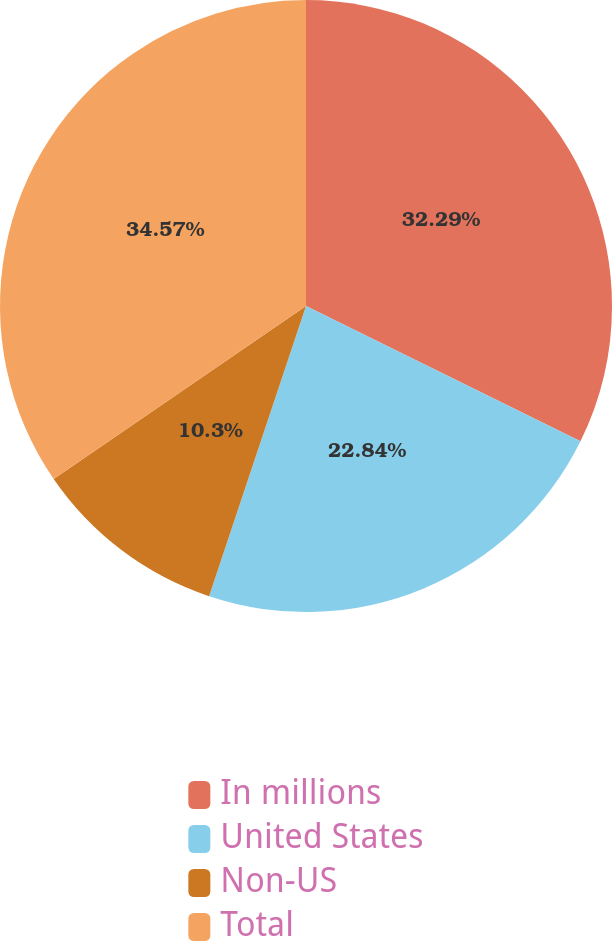Convert chart. <chart><loc_0><loc_0><loc_500><loc_500><pie_chart><fcel>In millions<fcel>United States<fcel>Non-US<fcel>Total<nl><fcel>32.29%<fcel>22.84%<fcel>10.3%<fcel>34.57%<nl></chart> 